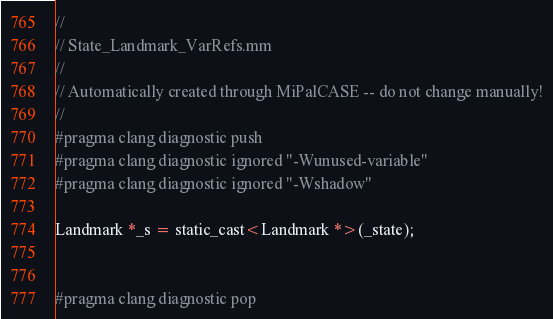Convert code to text. <code><loc_0><loc_0><loc_500><loc_500><_ObjectiveC_>//
// State_Landmark_VarRefs.mm
//
// Automatically created through MiPalCASE -- do not change manually!
//
#pragma clang diagnostic push
#pragma clang diagnostic ignored "-Wunused-variable"
#pragma clang diagnostic ignored "-Wshadow"

Landmark *_s = static_cast<Landmark *>(_state);


#pragma clang diagnostic pop
</code> 